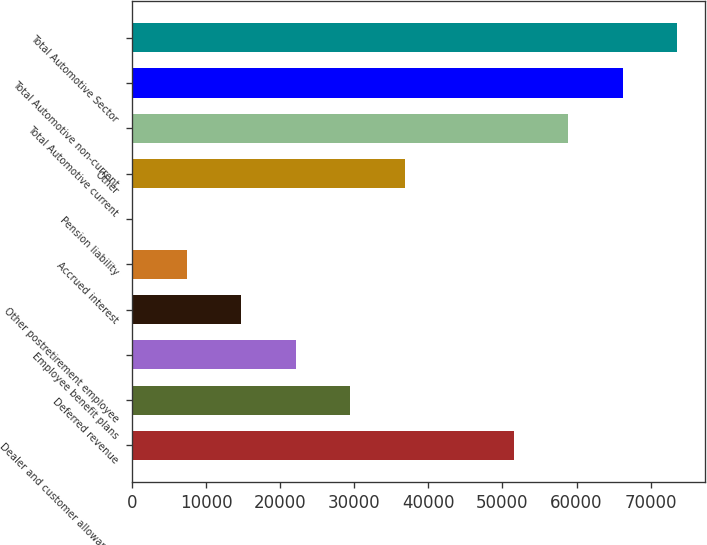Convert chart. <chart><loc_0><loc_0><loc_500><loc_500><bar_chart><fcel>Dealer and customer allowances<fcel>Deferred revenue<fcel>Employee benefit plans<fcel>Other postretirement employee<fcel>Accrued interest<fcel>Pension liability<fcel>Other<fcel>Total Automotive current<fcel>Total Automotive non-current<fcel>Total Automotive Sector<nl><fcel>51535.1<fcel>29478.2<fcel>22125.9<fcel>14773.6<fcel>7421.3<fcel>69<fcel>36830.5<fcel>58887.4<fcel>66239.7<fcel>73592<nl></chart> 